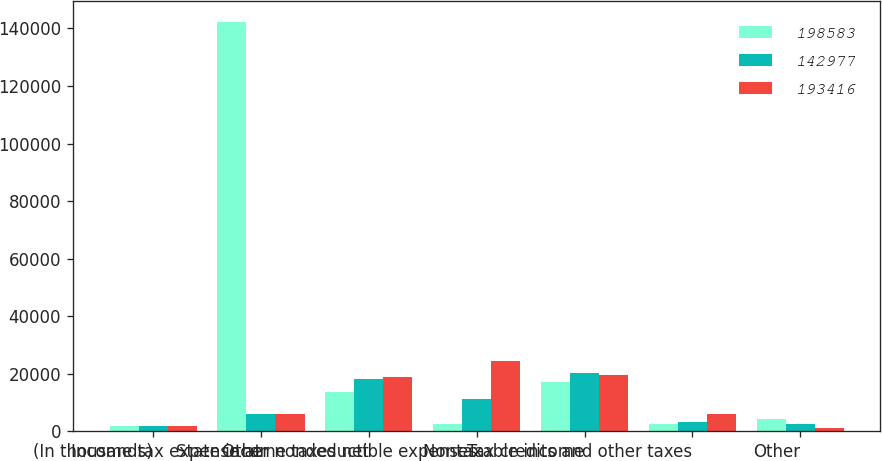Convert chart to OTSL. <chart><loc_0><loc_0><loc_500><loc_500><stacked_bar_chart><ecel><fcel>(In thousands)<fcel>Income tax expense at<fcel>State income taxes net<fcel>Other nondeductible expenses<fcel>Nontaxable income<fcel>Tax credits and other taxes<fcel>Other<nl><fcel>198583<fcel>2013<fcel>142251<fcel>13672<fcel>2574<fcel>17071<fcel>2628<fcel>4179<nl><fcel>142977<fcel>2012<fcel>5977<fcel>18264<fcel>11291<fcel>20137<fcel>3172<fcel>2378<nl><fcel>193416<fcel>2011<fcel>5977<fcel>18766<fcel>24361<fcel>19691<fcel>5977<fcel>1322<nl></chart> 